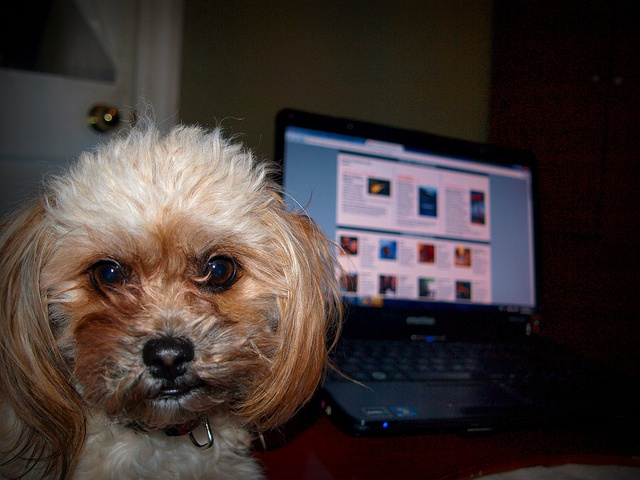Describe the objects in this image and their specific colors. I can see dog in black, gray, and maroon tones and laptop in black, darkgray, and gray tones in this image. 